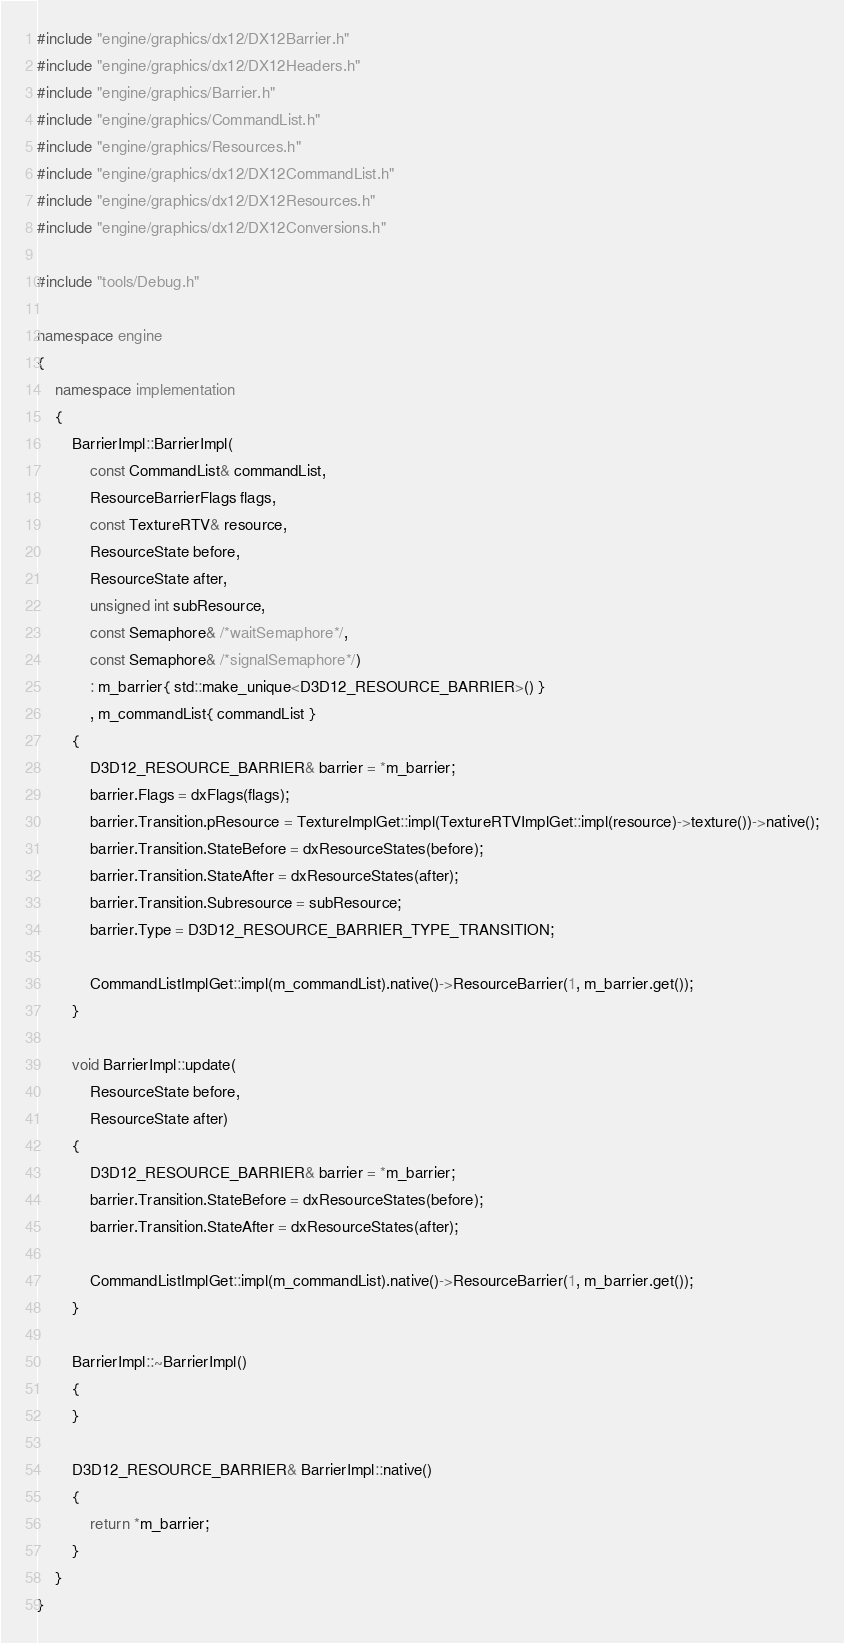<code> <loc_0><loc_0><loc_500><loc_500><_C++_>#include "engine/graphics/dx12/DX12Barrier.h"
#include "engine/graphics/dx12/DX12Headers.h"
#include "engine/graphics/Barrier.h"
#include "engine/graphics/CommandList.h"
#include "engine/graphics/Resources.h"
#include "engine/graphics/dx12/DX12CommandList.h"
#include "engine/graphics/dx12/DX12Resources.h"
#include "engine/graphics/dx12/DX12Conversions.h"

#include "tools/Debug.h"

namespace engine
{
    namespace implementation
    {
        BarrierImpl::BarrierImpl(
            const CommandList& commandList,
            ResourceBarrierFlags flags,
            const TextureRTV& resource,
            ResourceState before,
            ResourceState after,
            unsigned int subResource,
            const Semaphore& /*waitSemaphore*/,
            const Semaphore& /*signalSemaphore*/)
            : m_barrier{ std::make_unique<D3D12_RESOURCE_BARRIER>() }
            , m_commandList{ commandList }
        {
            D3D12_RESOURCE_BARRIER& barrier = *m_barrier;
            barrier.Flags = dxFlags(flags);
            barrier.Transition.pResource = TextureImplGet::impl(TextureRTVImplGet::impl(resource)->texture())->native();
            barrier.Transition.StateBefore = dxResourceStates(before);
            barrier.Transition.StateAfter = dxResourceStates(after);
            barrier.Transition.Subresource = subResource;
            barrier.Type = D3D12_RESOURCE_BARRIER_TYPE_TRANSITION;

            CommandListImplGet::impl(m_commandList).native()->ResourceBarrier(1, m_barrier.get());
        }

        void BarrierImpl::update(
            ResourceState before,
            ResourceState after)
        {
            D3D12_RESOURCE_BARRIER& barrier = *m_barrier;
            barrier.Transition.StateBefore = dxResourceStates(before);
            barrier.Transition.StateAfter = dxResourceStates(after);
            
            CommandListImplGet::impl(m_commandList).native()->ResourceBarrier(1, m_barrier.get());
        }

        BarrierImpl::~BarrierImpl()
        {
        }

        D3D12_RESOURCE_BARRIER& BarrierImpl::native()
        {
            return *m_barrier;
        }
    }
}
</code> 